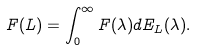<formula> <loc_0><loc_0><loc_500><loc_500>F ( L ) = \int _ { 0 } ^ { \infty } F ( \lambda ) d E _ { L } ( \lambda ) .</formula> 